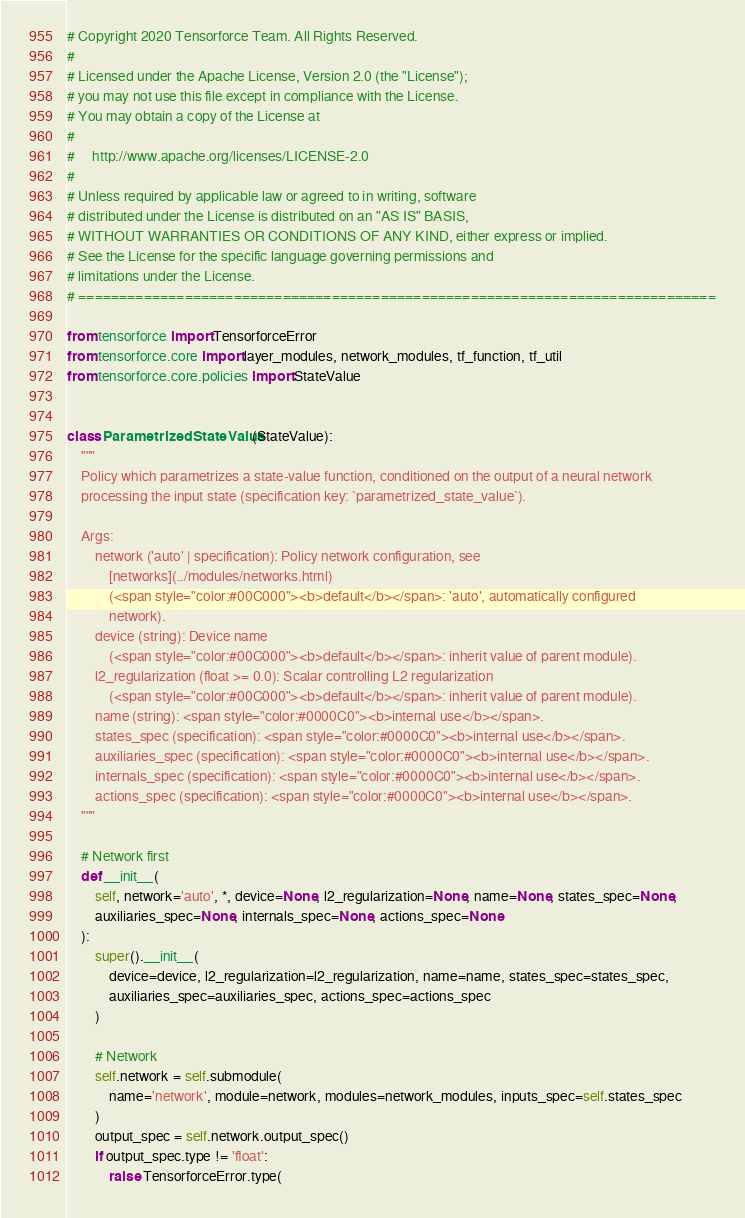Convert code to text. <code><loc_0><loc_0><loc_500><loc_500><_Python_># Copyright 2020 Tensorforce Team. All Rights Reserved.
#
# Licensed under the Apache License, Version 2.0 (the "License");
# you may not use this file except in compliance with the License.
# You may obtain a copy of the License at
#
#     http://www.apache.org/licenses/LICENSE-2.0
#
# Unless required by applicable law or agreed to in writing, software
# distributed under the License is distributed on an "AS IS" BASIS,
# WITHOUT WARRANTIES OR CONDITIONS OF ANY KIND, either express or implied.
# See the License for the specific language governing permissions and
# limitations under the License.
# ==============================================================================

from tensorforce import TensorforceError
from tensorforce.core import layer_modules, network_modules, tf_function, tf_util
from tensorforce.core.policies import StateValue


class ParametrizedStateValue(StateValue):
    """
    Policy which parametrizes a state-value function, conditioned on the output of a neural network
    processing the input state (specification key: `parametrized_state_value`).

    Args:
        network ('auto' | specification): Policy network configuration, see
            [networks](../modules/networks.html)
            (<span style="color:#00C000"><b>default</b></span>: 'auto', automatically configured
            network).
        device (string): Device name
            (<span style="color:#00C000"><b>default</b></span>: inherit value of parent module).
        l2_regularization (float >= 0.0): Scalar controlling L2 regularization
            (<span style="color:#00C000"><b>default</b></span>: inherit value of parent module).
        name (string): <span style="color:#0000C0"><b>internal use</b></span>.
        states_spec (specification): <span style="color:#0000C0"><b>internal use</b></span>.
        auxiliaries_spec (specification): <span style="color:#0000C0"><b>internal use</b></span>.
        internals_spec (specification): <span style="color:#0000C0"><b>internal use</b></span>.
        actions_spec (specification): <span style="color:#0000C0"><b>internal use</b></span>.
    """

    # Network first
    def __init__(
        self, network='auto', *, device=None, l2_regularization=None, name=None, states_spec=None,
        auxiliaries_spec=None, internals_spec=None, actions_spec=None
    ):
        super().__init__(
            device=device, l2_regularization=l2_regularization, name=name, states_spec=states_spec,
            auxiliaries_spec=auxiliaries_spec, actions_spec=actions_spec
        )

        # Network
        self.network = self.submodule(
            name='network', module=network, modules=network_modules, inputs_spec=self.states_spec
        )
        output_spec = self.network.output_spec()
        if output_spec.type != 'float':
            raise TensorforceError.type(</code> 